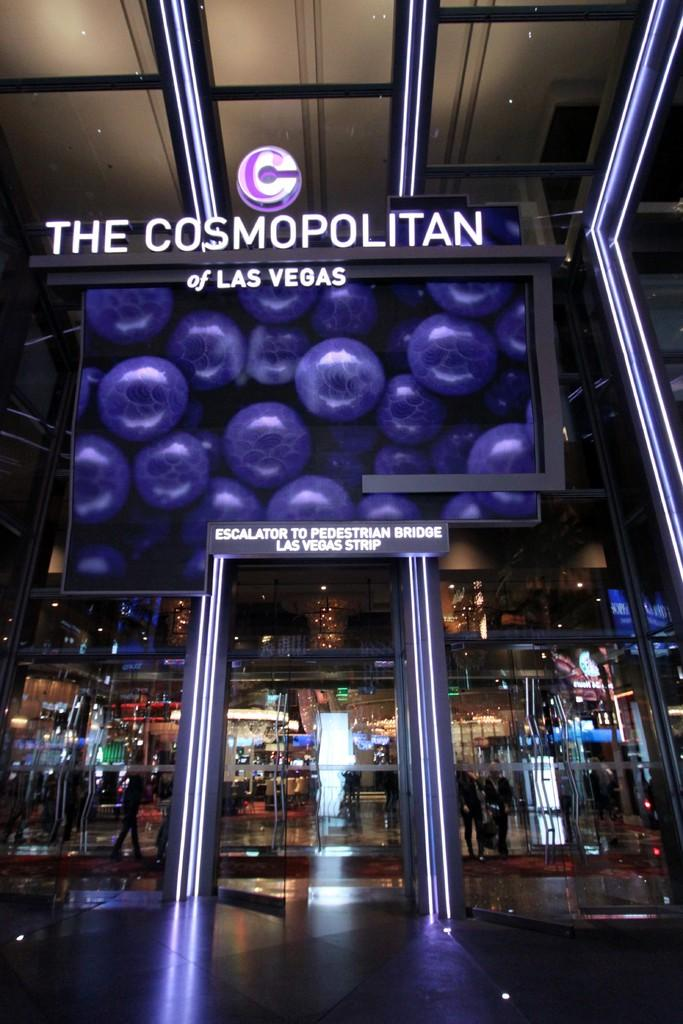<image>
Describe the image concisely. Entrance for The Cosmopolitan of Las Vegas in purple. 